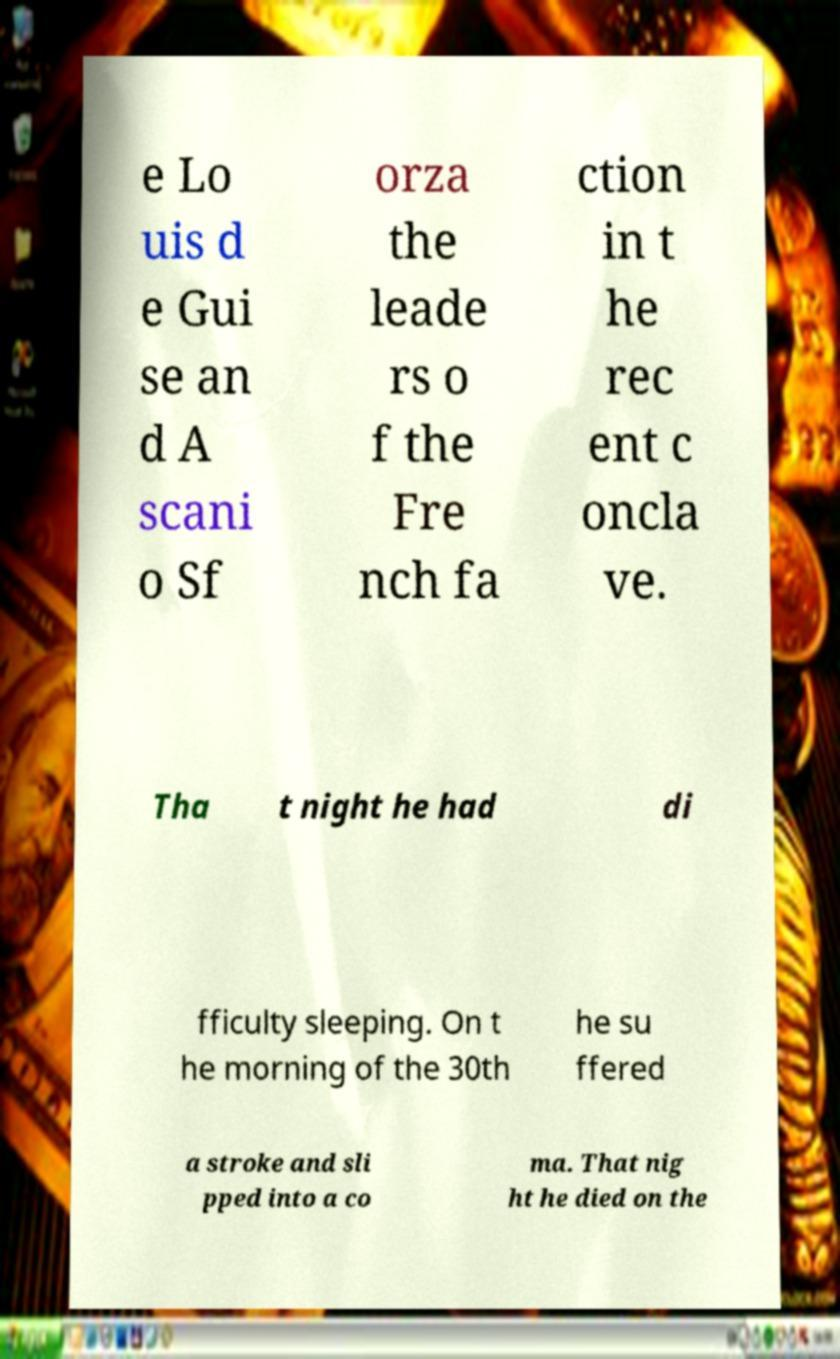Please read and relay the text visible in this image. What does it say? e Lo uis d e Gui se an d A scani o Sf orza the leade rs o f the Fre nch fa ction in t he rec ent c oncla ve. Tha t night he had di fficulty sleeping. On t he morning of the 30th he su ffered a stroke and sli pped into a co ma. That nig ht he died on the 